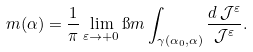Convert formula to latex. <formula><loc_0><loc_0><loc_500><loc_500>m ( \alpha ) = \frac { 1 } { \pi } \lim _ { \varepsilon \to + 0 } \i m \int _ { \gamma ( \alpha _ { 0 } , \alpha ) } \frac { d \, \mathcal { J } ^ { \varepsilon } } { \mathcal { J } ^ { \varepsilon } } .</formula> 